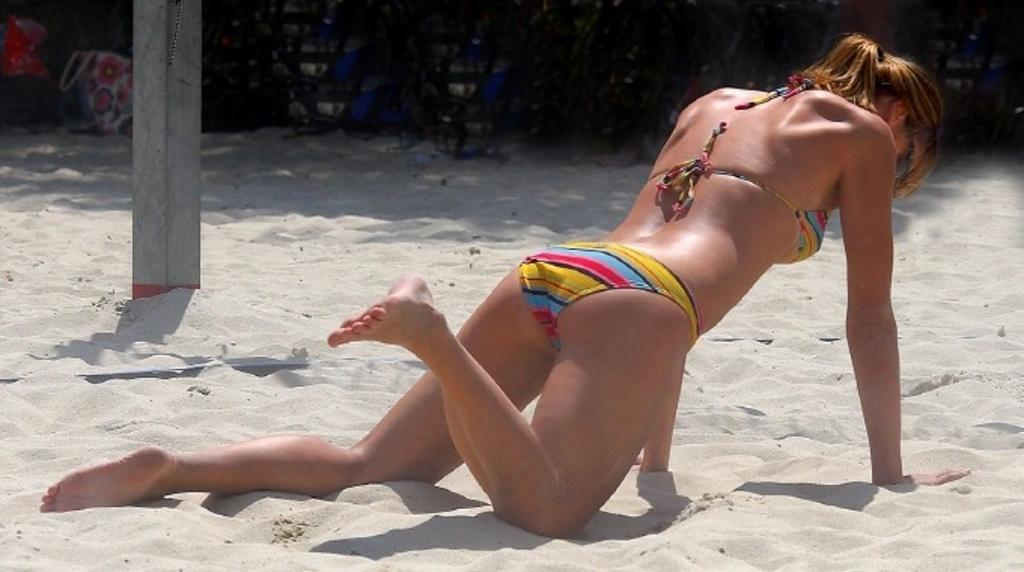Who is present in the image? There is a woman in the image. What is the woman standing on? The woman is on the sand. What can be seen in the background of the image? There are bags and a pole in the background of the image. What language is the bird speaking in the image? There is no bird present in the image, so it is not possible to determine what language it might be speaking. 